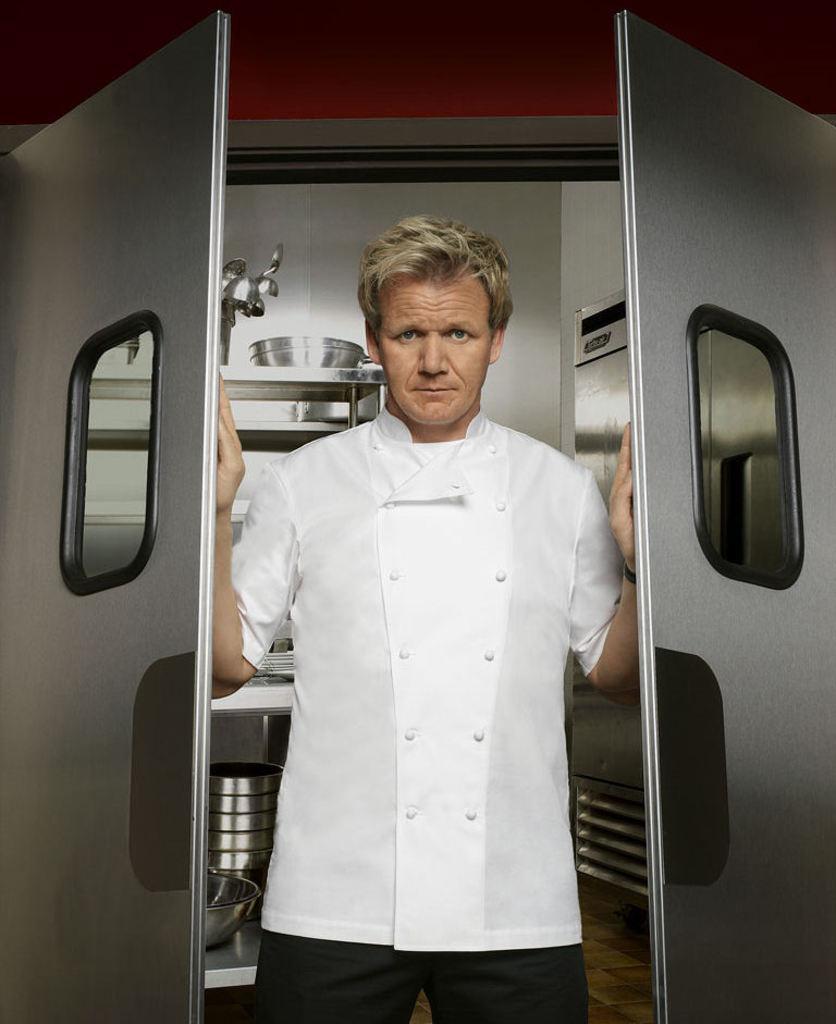In one or two sentences, can you explain what this image depicts? In this image in the center there is one man who is standing and he is opening the door It seems, and in the background there are some steel vessels and there is wall. At the bottom there is floor. 